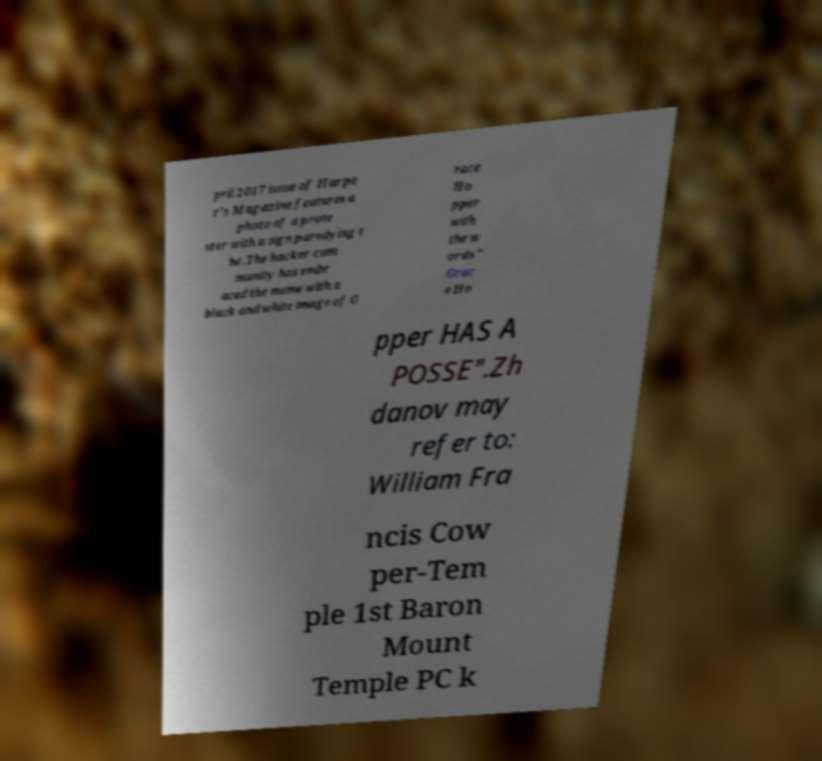Can you accurately transcribe the text from the provided image for me? pril 2017 issue of Harpe r's Magazine features a photo of a prote ster with a sign parodying t he .The hacker com munity has embr aced the meme with a black and white image of G race Ho pper with the w ords " Grac e Ho pper HAS A POSSE".Zh danov may refer to: William Fra ncis Cow per-Tem ple 1st Baron Mount Temple PC k 